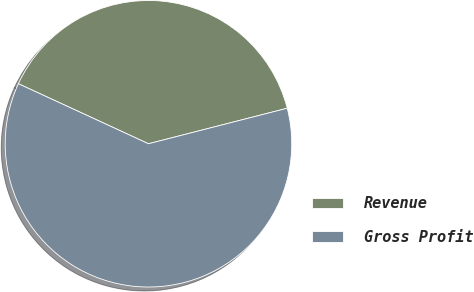Convert chart to OTSL. <chart><loc_0><loc_0><loc_500><loc_500><pie_chart><fcel>Revenue<fcel>Gross Profit<nl><fcel>39.13%<fcel>60.87%<nl></chart> 